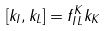Convert formula to latex. <formula><loc_0><loc_0><loc_500><loc_500>[ k _ { I } , k _ { L } ] = f _ { I L } ^ { K } k _ { K }</formula> 